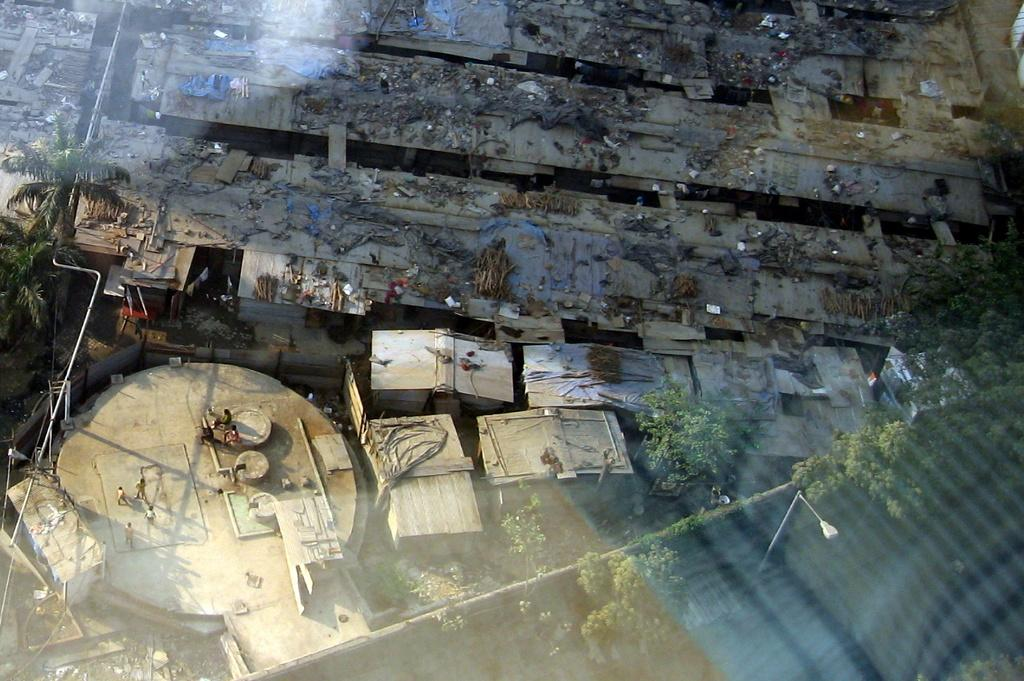What type of structures are visible in the image? There are houses in the image. What type of vegetation is present in the image? There are trees and creepers in the image. What type of lighting infrastructure is visible in the image? There are light poles in the image. What is the position of the group of people in the image? The group of people is on the ground in the image. What time of day does the image appear to be taken? The image appears to be taken during the day. Who is controlling the group of people in the image? There is no indication in the image that anyone is controlling the group of people. Can you see the grandfather in the image? There is no mention of a grandfather in the image, and no person is specifically identified as a grandfather. 